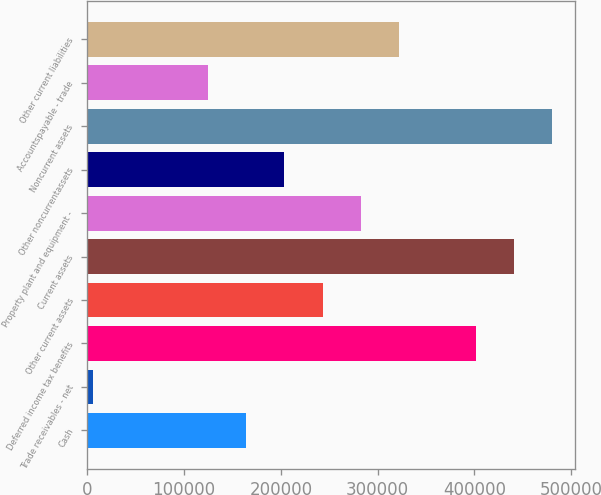<chart> <loc_0><loc_0><loc_500><loc_500><bar_chart><fcel>Cash<fcel>Trade receivables - net<fcel>Deferred income tax benefits<fcel>Other current assets<fcel>Current assets<fcel>Property plant and equipment -<fcel>Other noncurrentassets<fcel>Noncurrent assets<fcel>Accountspayable - trade<fcel>Other current liabilities<nl><fcel>164175<fcel>6101<fcel>401285<fcel>243211<fcel>440803<fcel>282730<fcel>203693<fcel>480322<fcel>124656<fcel>322248<nl></chart> 